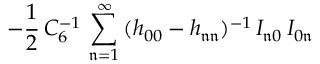Convert formula to latex. <formula><loc_0><loc_0><loc_500><loc_500>- \frac { 1 } { 2 } \, C _ { 6 } ^ { - 1 } \, \sum _ { \mathfrak { n } = 1 } ^ { \infty } \, ( h _ { 0 0 } - h _ { \mathfrak { n } \mathfrak { n } } ) ^ { - 1 } \, I _ { \mathfrak { n } 0 } \, I _ { 0 \mathfrak { n } }</formula> 